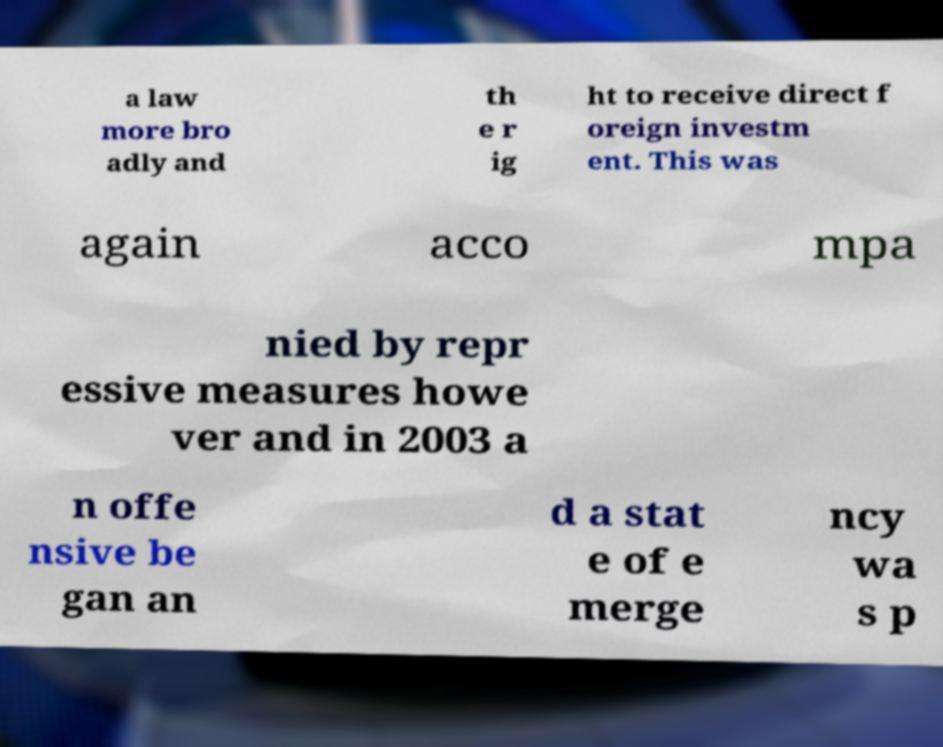There's text embedded in this image that I need extracted. Can you transcribe it verbatim? a law more bro adly and th e r ig ht to receive direct f oreign investm ent. This was again acco mpa nied by repr essive measures howe ver and in 2003 a n offe nsive be gan an d a stat e of e merge ncy wa s p 